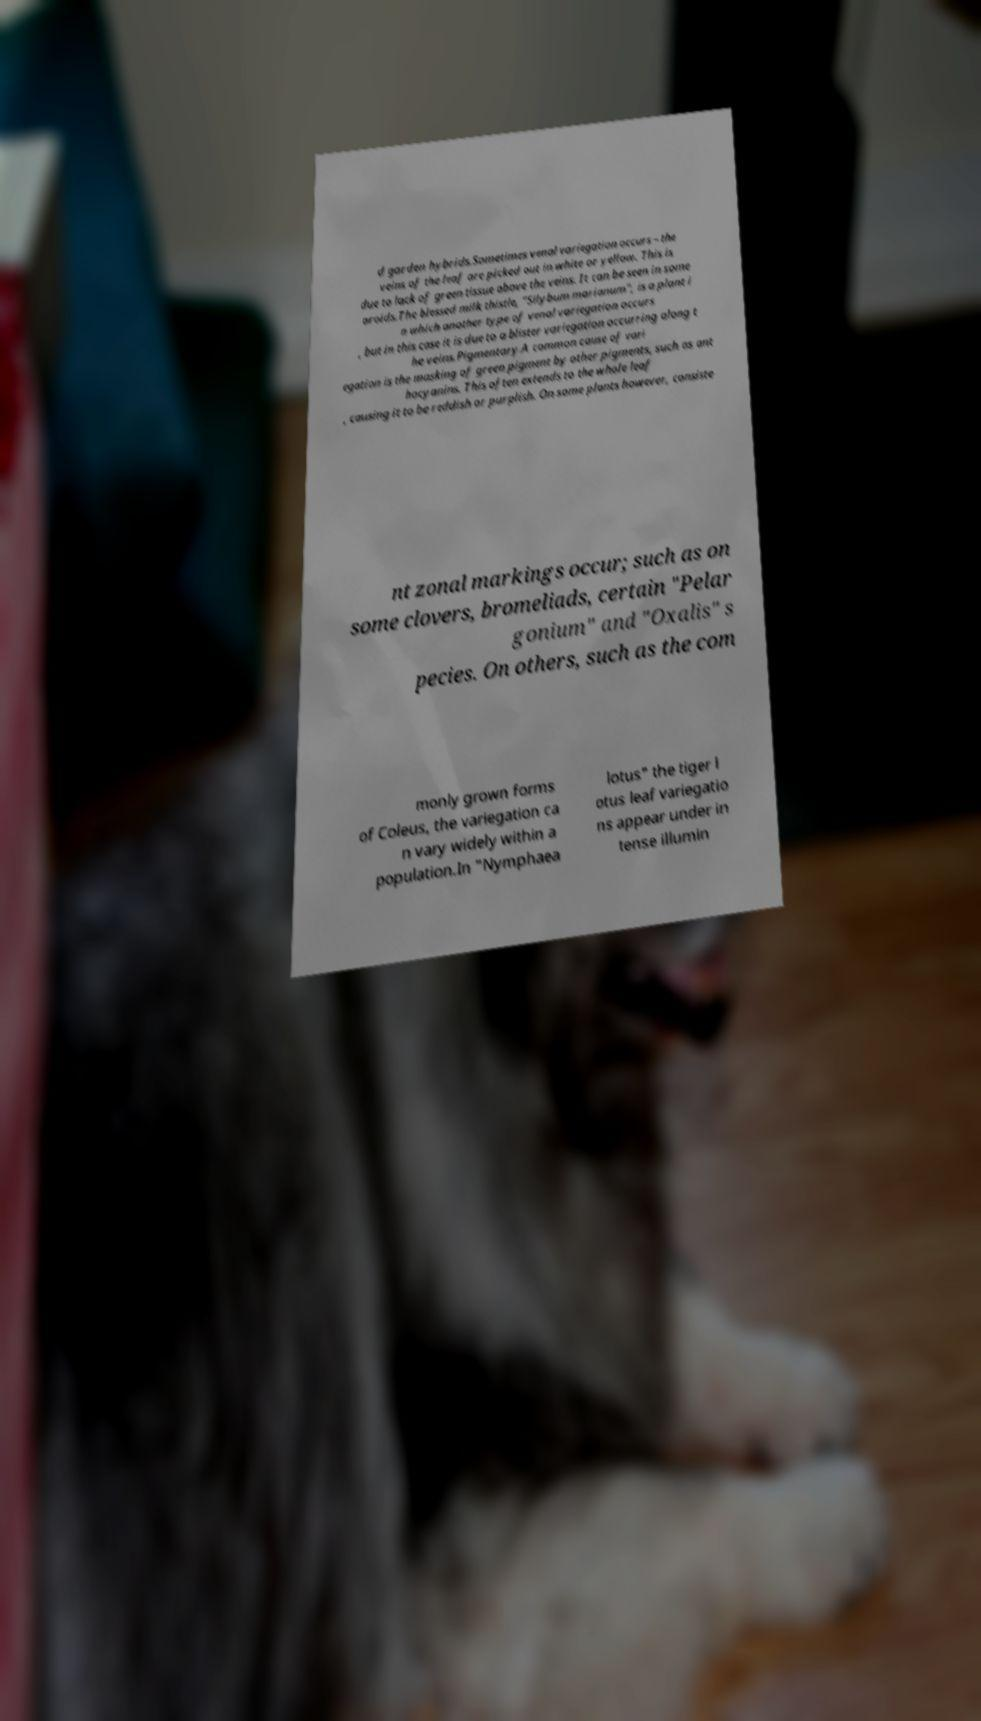Please identify and transcribe the text found in this image. d garden hybrids.Sometimes venal variegation occurs – the veins of the leaf are picked out in white or yellow. This is due to lack of green tissue above the veins. It can be seen in some aroids.The blessed milk thistle, "Silybum marianum", is a plant i n which another type of venal variegation occurs , but in this case it is due to a blister variegation occurring along t he veins.Pigmentary.A common cause of vari egation is the masking of green pigment by other pigments, such as ant hocyanins. This often extends to the whole leaf , causing it to be reddish or purplish. On some plants however, consiste nt zonal markings occur; such as on some clovers, bromeliads, certain "Pelar gonium" and "Oxalis" s pecies. On others, such as the com monly grown forms of Coleus, the variegation ca n vary widely within a population.In "Nymphaea lotus" the tiger l otus leaf variegatio ns appear under in tense illumin 